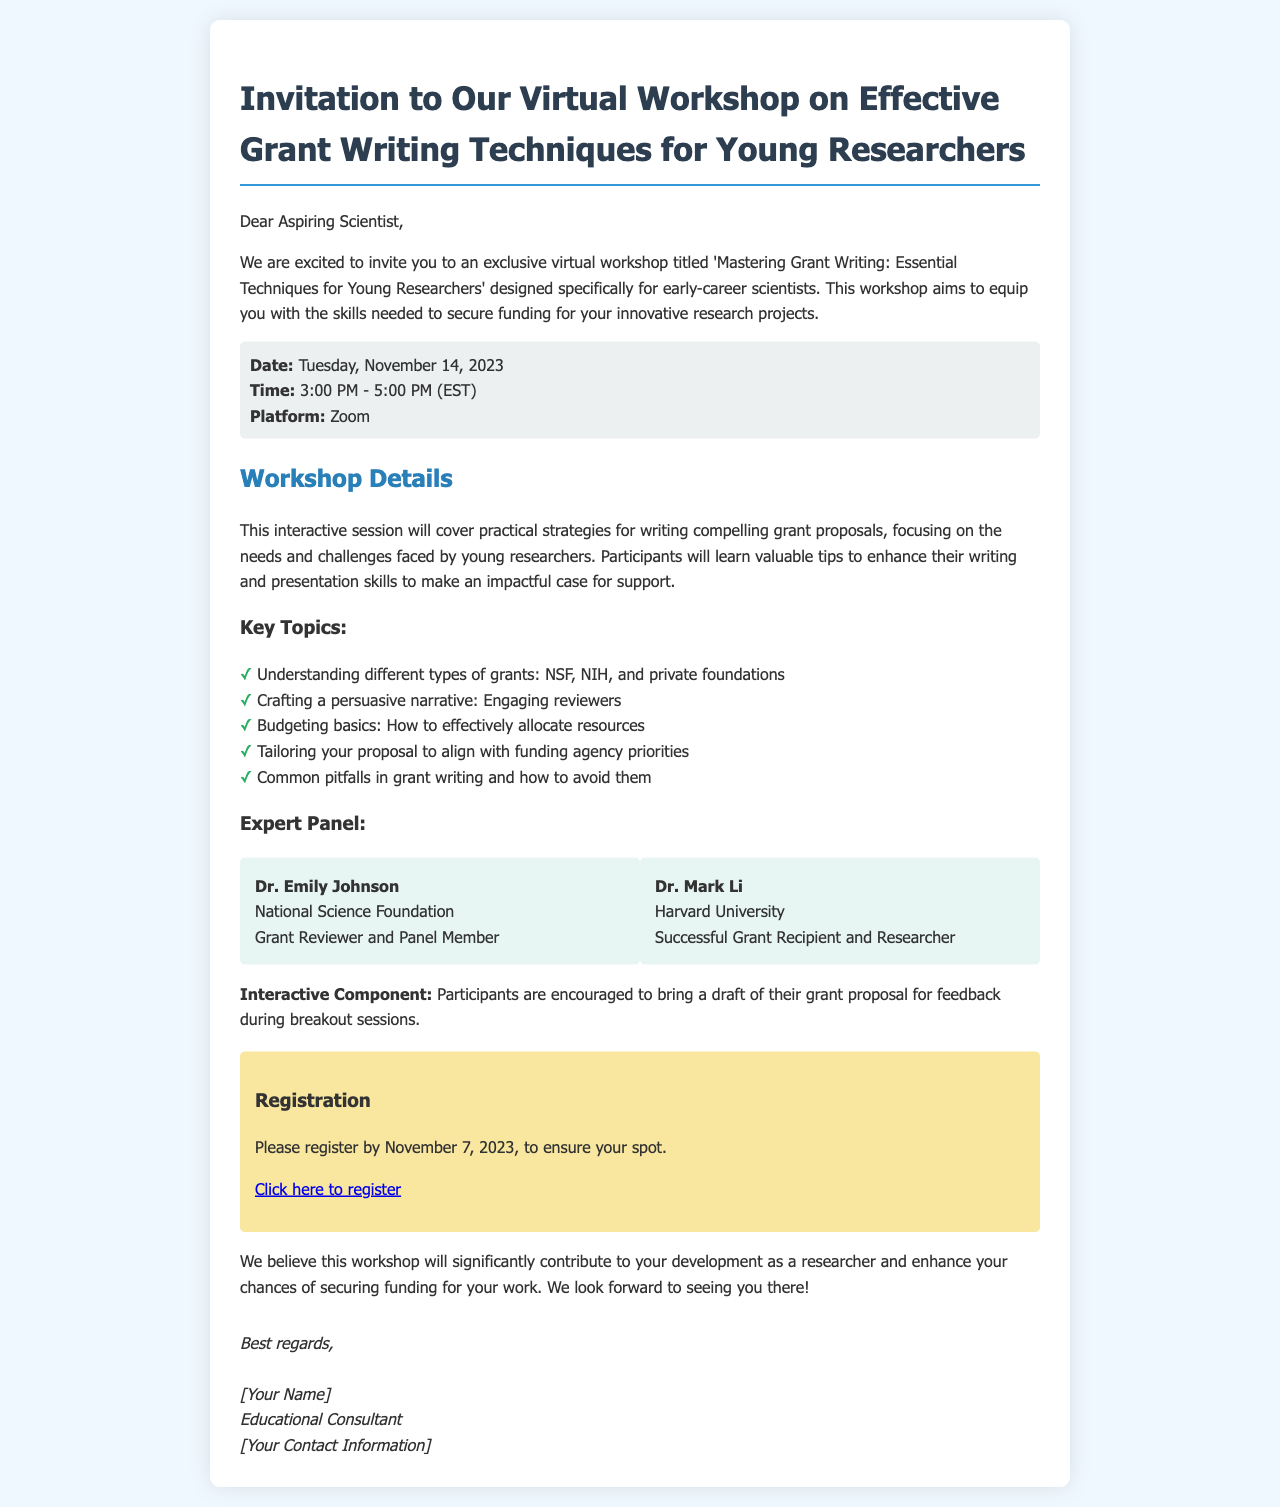What is the title of the workshop? The title is explicitly stated at the beginning of the invitation.
Answer: Mastering Grant Writing: Essential Techniques for Young Researchers When is the workshop scheduled? The date is prominently displayed in the date-time section of the document.
Answer: Tuesday, November 14, 2023 What is the duration of the workshop? The time period for the workshop is mentioned in the date-time section.
Answer: 3:00 PM - 5:00 PM Who are the experts leading the workshop? The names of the experts are provided in the expert panel section.
Answer: Dr. Emily Johnson and Dr. Mark Li What is one of the key topics covered in the workshop? The key topics are listed in a bulleted format within the workshop details.
Answer: Understanding different types of grants: NSF, NIH, and private foundations What platform will the workshop be conducted on? The platform for the virtual workshop is mentioned in the date-time section.
Answer: Zoom When is the registration deadline? The deadline for registration is specifically stated in the registration section.
Answer: November 7, 2023 Are participants encouraged to bring anything to the workshop? This information is found in the paragraph about the interactive component.
Answer: A draft of their grant proposal What should participants do to secure their spot? The call to action for registration is mentioned in the registration section.
Answer: Register by November 7, 2023 